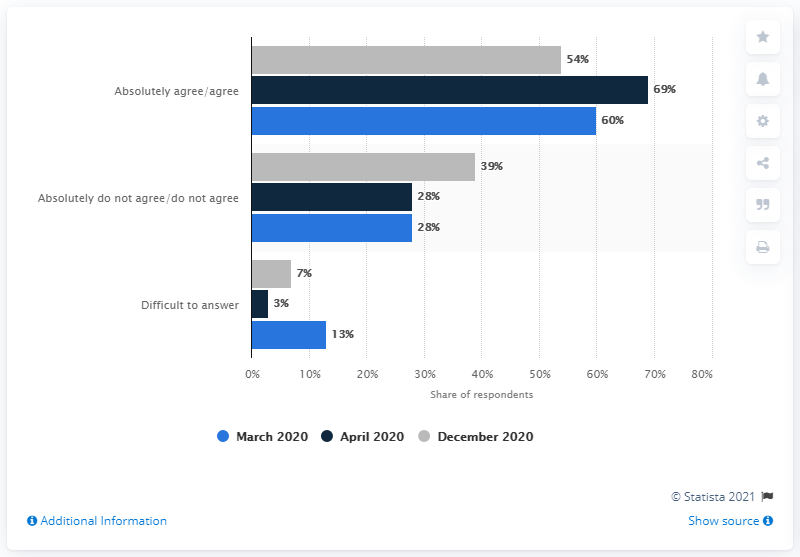Mention a couple of crucial points in this snapshot. A recent survey revealed that 54% of Russians were willing to sacrifice some of their rights if it helped to contain the coronavirus outbreak. 